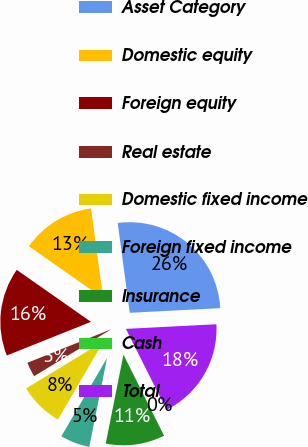Convert chart to OTSL. <chart><loc_0><loc_0><loc_500><loc_500><pie_chart><fcel>Asset Category<fcel>Domestic equity<fcel>Foreign equity<fcel>Real estate<fcel>Domestic fixed income<fcel>Foreign fixed income<fcel>Insurance<fcel>Cash<fcel>Total<nl><fcel>26.3%<fcel>13.16%<fcel>15.78%<fcel>2.64%<fcel>7.9%<fcel>5.27%<fcel>10.53%<fcel>0.01%<fcel>18.41%<nl></chart> 